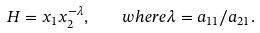Convert formula to latex. <formula><loc_0><loc_0><loc_500><loc_500>H = x _ { 1 } x _ { 2 } ^ { - \lambda } , \quad w h e r e \lambda = a _ { 1 1 } / a _ { 2 1 } .</formula> 